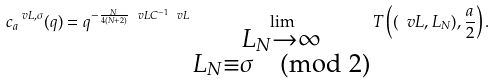<formula> <loc_0><loc_0><loc_500><loc_500>c _ { a } ^ { \ v L , \sigma } ( q ) = q ^ { - \frac { N } { 4 ( N + 2 ) } \ v L C ^ { - 1 } \ v L } \lim _ { \substack { L _ { N } \to \infty \\ L _ { N } \equiv \sigma \pmod { 2 } } } T \left ( ( \ v L , L _ { N } ) , \frac { a } { 2 } \right ) .</formula> 